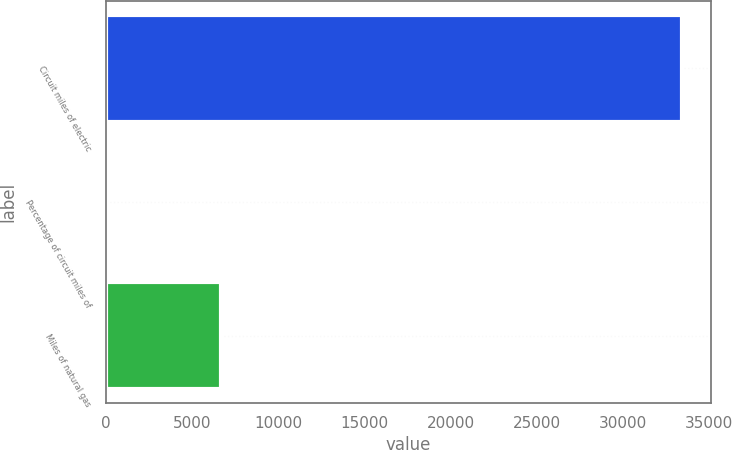Convert chart to OTSL. <chart><loc_0><loc_0><loc_500><loc_500><bar_chart><fcel>Circuit miles of electric<fcel>Percentage of circuit miles of<fcel>Miles of natural gas<nl><fcel>33414<fcel>23<fcel>6701.2<nl></chart> 